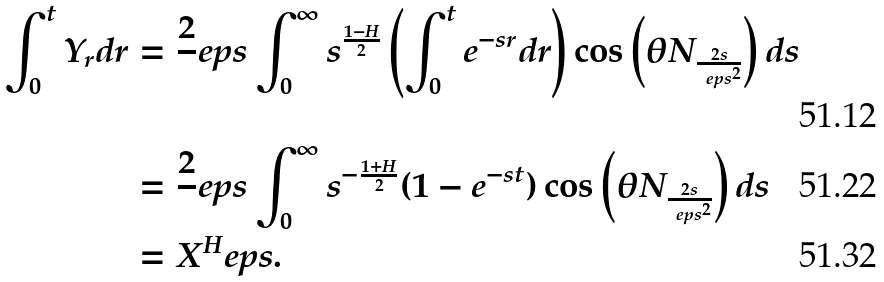<formula> <loc_0><loc_0><loc_500><loc_500>\int _ { 0 } ^ { t } Y _ { r } d r & = \frac { 2 } { \ } e p s \int _ { 0 } ^ { \infty } s ^ { \frac { 1 - H } 2 } \left ( \int _ { 0 } ^ { t } e ^ { - s r } d r \right ) \cos \left ( \theta N _ { \frac { 2 s } { \ e p s ^ { 2 } } } \right ) d s \\ & = \frac { 2 } { \ } e p s \int _ { 0 } ^ { \infty } s ^ { - { \frac { 1 + H } 2 } } ( 1 - e ^ { - s t } ) \cos \left ( \theta N _ { \frac { 2 s } { \ e p s ^ { 2 } } } \right ) d s \\ & = X ^ { H } _ { \ } e p s .</formula> 